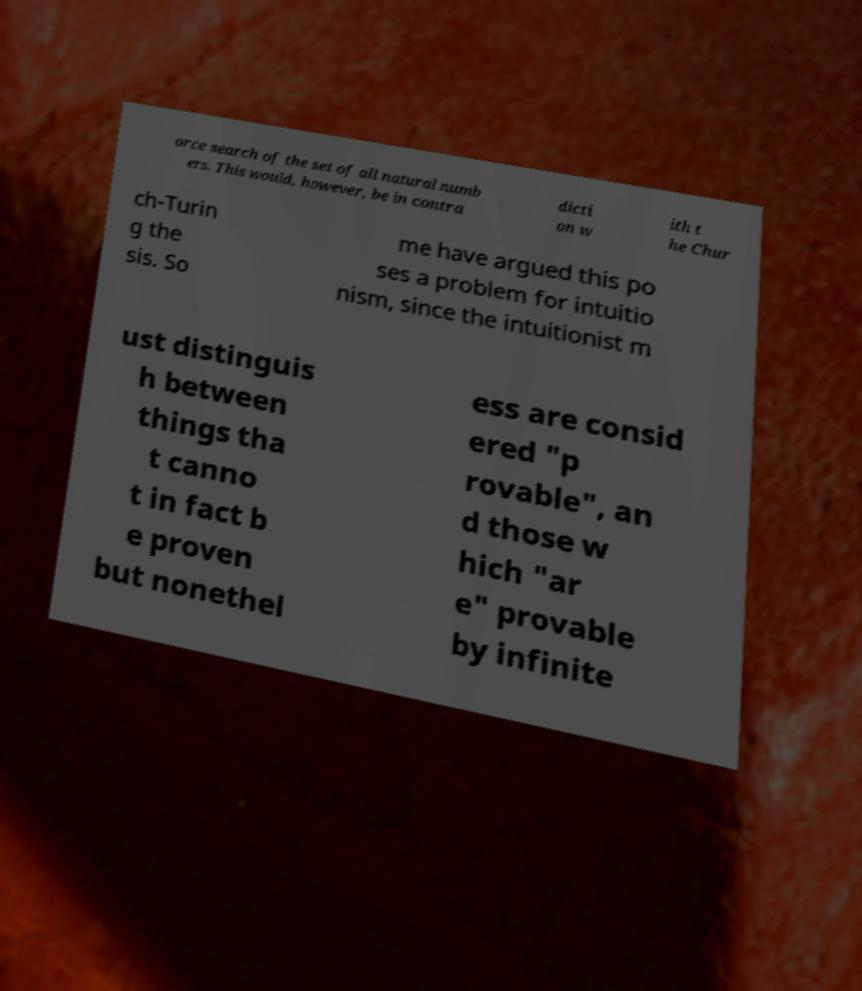Could you extract and type out the text from this image? orce search of the set of all natural numb ers. This would, however, be in contra dicti on w ith t he Chur ch-Turin g the sis. So me have argued this po ses a problem for intuitio nism, since the intuitionist m ust distinguis h between things tha t canno t in fact b e proven but nonethel ess are consid ered "p rovable", an d those w hich "ar e" provable by infinite 